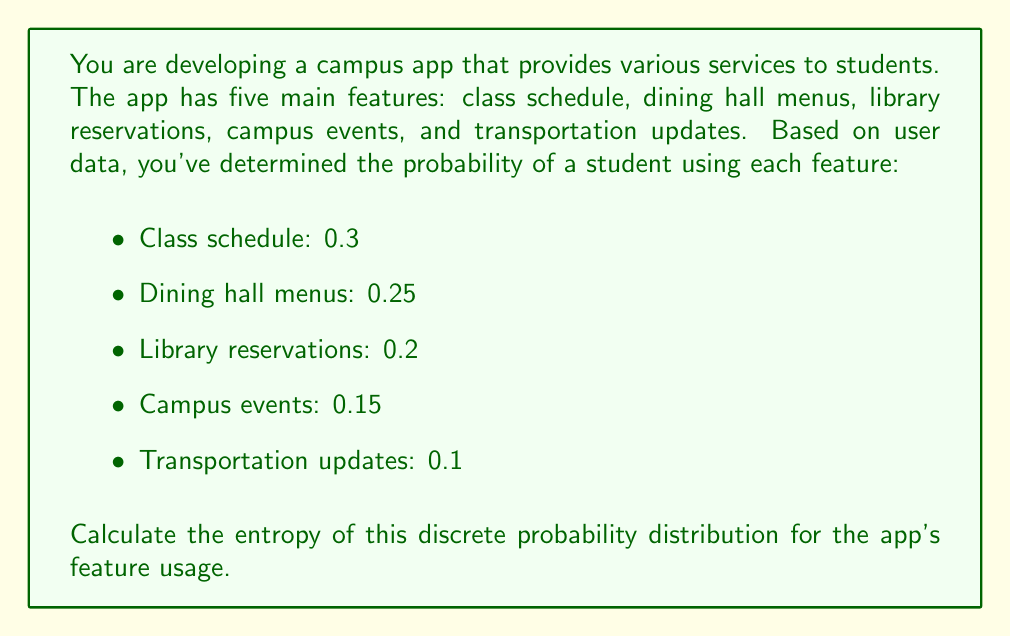Could you help me with this problem? To calculate the entropy of a discrete probability distribution, we use the formula:

$$H = -\sum_{i=1}^{n} p_i \log_2(p_i)$$

Where:
- $H$ is the entropy
- $p_i$ is the probability of each event
- $n$ is the number of possible events

Let's calculate for each feature:

1. Class schedule: $-0.3 \log_2(0.3)$
2. Dining hall menus: $-0.25 \log_2(0.25)$
3. Library reservations: $-0.2 \log_2(0.2)$
4. Campus events: $-0.15 \log_2(0.15)$
5. Transportation updates: $-0.1 \log_2(0.1)$

Now, let's compute each term:

1. $-0.3 \log_2(0.3) \approx 0.5211$
2. $-0.25 \log_2(0.25) \approx 0.5$
3. $-0.2 \log_2(0.2) \approx 0.4644$
4. $-0.15 \log_2(0.15) \approx 0.4105$
5. $-0.1 \log_2(0.1) \approx 0.3322$

Sum all these values:

$$H = 0.5211 + 0.5 + 0.4644 + 0.4105 + 0.3322 = 2.2282$$

Therefore, the entropy of the discrete probability distribution for the app's feature usage is approximately 2.2282 bits.
Answer: $H \approx 2.2282$ bits 